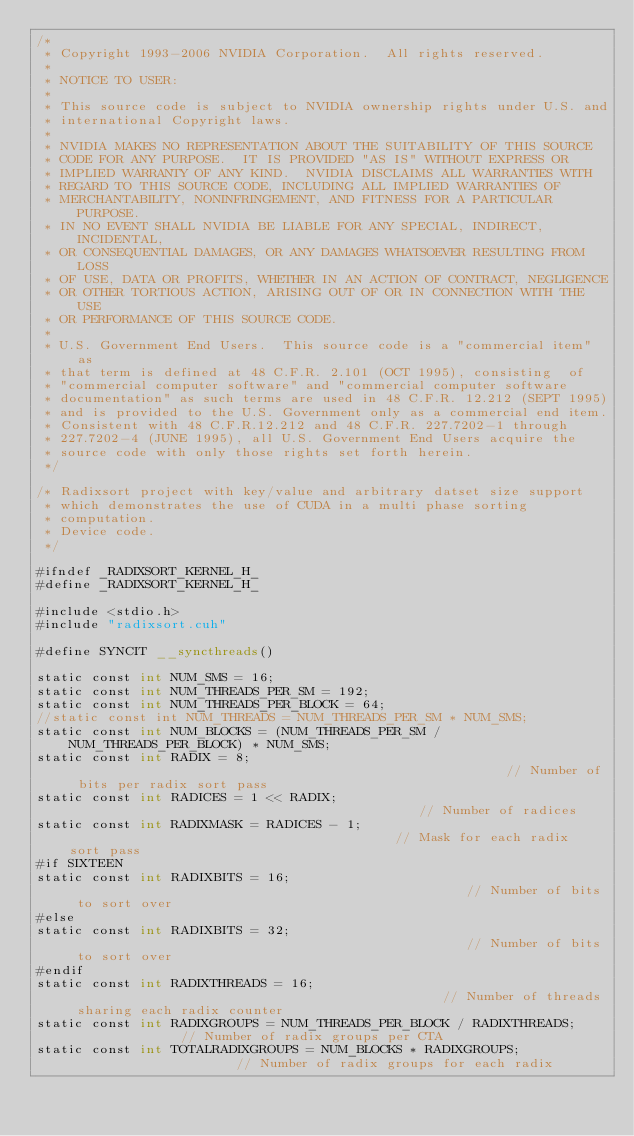Convert code to text. <code><loc_0><loc_0><loc_500><loc_500><_Cuda_>/*
 * Copyright 1993-2006 NVIDIA Corporation.  All rights reserved.
 *
 * NOTICE TO USER:   
 *
 * This source code is subject to NVIDIA ownership rights under U.S. and 
 * international Copyright laws.  
 *
 * NVIDIA MAKES NO REPRESENTATION ABOUT THE SUITABILITY OF THIS SOURCE 
 * CODE FOR ANY PURPOSE.  IT IS PROVIDED "AS IS" WITHOUT EXPRESS OR 
 * IMPLIED WARRANTY OF ANY KIND.  NVIDIA DISCLAIMS ALL WARRANTIES WITH 
 * REGARD TO THIS SOURCE CODE, INCLUDING ALL IMPLIED WARRANTIES OF 
 * MERCHANTABILITY, NONINFRINGEMENT, AND FITNESS FOR A PARTICULAR PURPOSE.   
 * IN NO EVENT SHALL NVIDIA BE LIABLE FOR ANY SPECIAL, INDIRECT, INCIDENTAL, 
 * OR CONSEQUENTIAL DAMAGES, OR ANY DAMAGES WHATSOEVER RESULTING FROM LOSS 
 * OF USE, DATA OR PROFITS, WHETHER IN AN ACTION OF CONTRACT, NEGLIGENCE 
 * OR OTHER TORTIOUS ACTION, ARISING OUT OF OR IN CONNECTION WITH THE USE 
 * OR PERFORMANCE OF THIS SOURCE CODE.  
 *
 * U.S. Government End Users.  This source code is a "commercial item" as 
 * that term is defined at 48 C.F.R. 2.101 (OCT 1995), consisting  of 
 * "commercial computer software" and "commercial computer software 
 * documentation" as such terms are used in 48 C.F.R. 12.212 (SEPT 1995) 
 * and is provided to the U.S. Government only as a commercial end item.  
 * Consistent with 48 C.F.R.12.212 and 48 C.F.R. 227.7202-1 through 
 * 227.7202-4 (JUNE 1995), all U.S. Government End Users acquire the 
 * source code with only those rights set forth herein.
 */

/* Radixsort project with key/value and arbitrary datset size support
 * which demonstrates the use of CUDA in a multi phase sorting 
 * computation.
 * Device code.
 */

#ifndef _RADIXSORT_KERNEL_H_
#define _RADIXSORT_KERNEL_H_

#include <stdio.h>
#include "radixsort.cuh"

#define SYNCIT __syncthreads()

static const int NUM_SMS = 16;
static const int NUM_THREADS_PER_SM = 192;
static const int NUM_THREADS_PER_BLOCK = 64;
//static const int NUM_THREADS = NUM_THREADS_PER_SM * NUM_SMS;
static const int NUM_BLOCKS = (NUM_THREADS_PER_SM / NUM_THREADS_PER_BLOCK) * NUM_SMS;
static const int RADIX = 8;                                                        // Number of bits per radix sort pass
static const int RADICES = 1 << RADIX;                                             // Number of radices
static const int RADIXMASK = RADICES - 1;                                          // Mask for each radix sort pass
#if SIXTEEN
static const int RADIXBITS = 16;                                                   // Number of bits to sort over
#else
static const int RADIXBITS = 32;                                                   // Number of bits to sort over
#endif
static const int RADIXTHREADS = 16;                                                // Number of threads sharing each radix counter
static const int RADIXGROUPS = NUM_THREADS_PER_BLOCK / RADIXTHREADS;               // Number of radix groups per CTA
static const int TOTALRADIXGROUPS = NUM_BLOCKS * RADIXGROUPS;                      // Number of radix groups for each radix</code> 